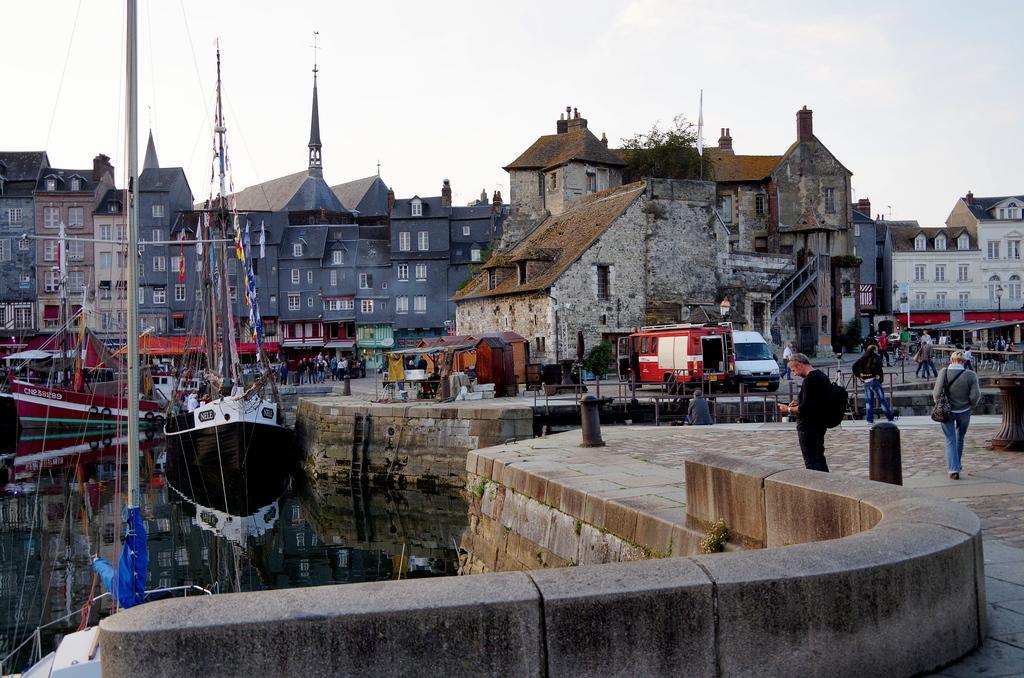In one or two sentences, can you explain what this image depicts? In this image, on the left side, we can see water, there are some boats on the water, on the right side there is a floor and we can see some people walking, we can see two vans, there are some buildings, at the top we can see the sky. 